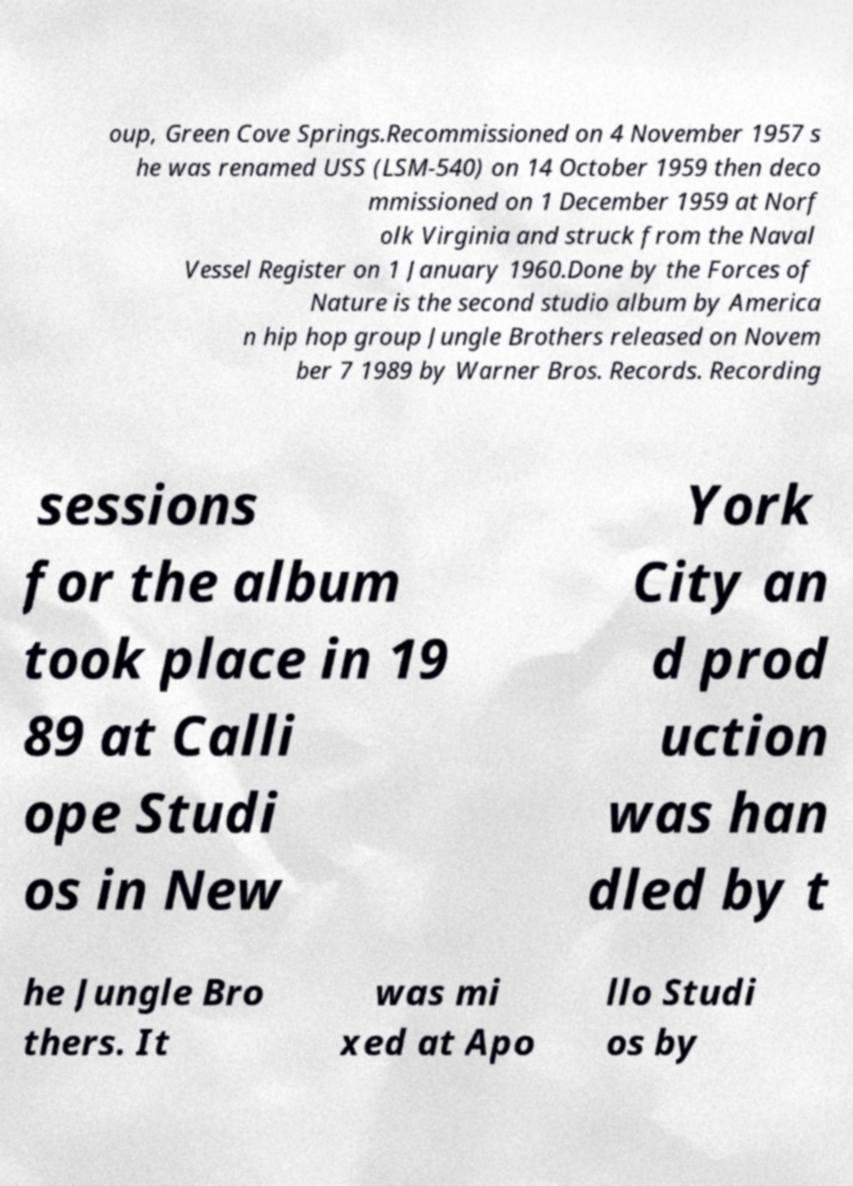There's text embedded in this image that I need extracted. Can you transcribe it verbatim? oup, Green Cove Springs.Recommissioned on 4 November 1957 s he was renamed USS (LSM-540) on 14 October 1959 then deco mmissioned on 1 December 1959 at Norf olk Virginia and struck from the Naval Vessel Register on 1 January 1960.Done by the Forces of Nature is the second studio album by America n hip hop group Jungle Brothers released on Novem ber 7 1989 by Warner Bros. Records. Recording sessions for the album took place in 19 89 at Calli ope Studi os in New York City an d prod uction was han dled by t he Jungle Bro thers. It was mi xed at Apo llo Studi os by 